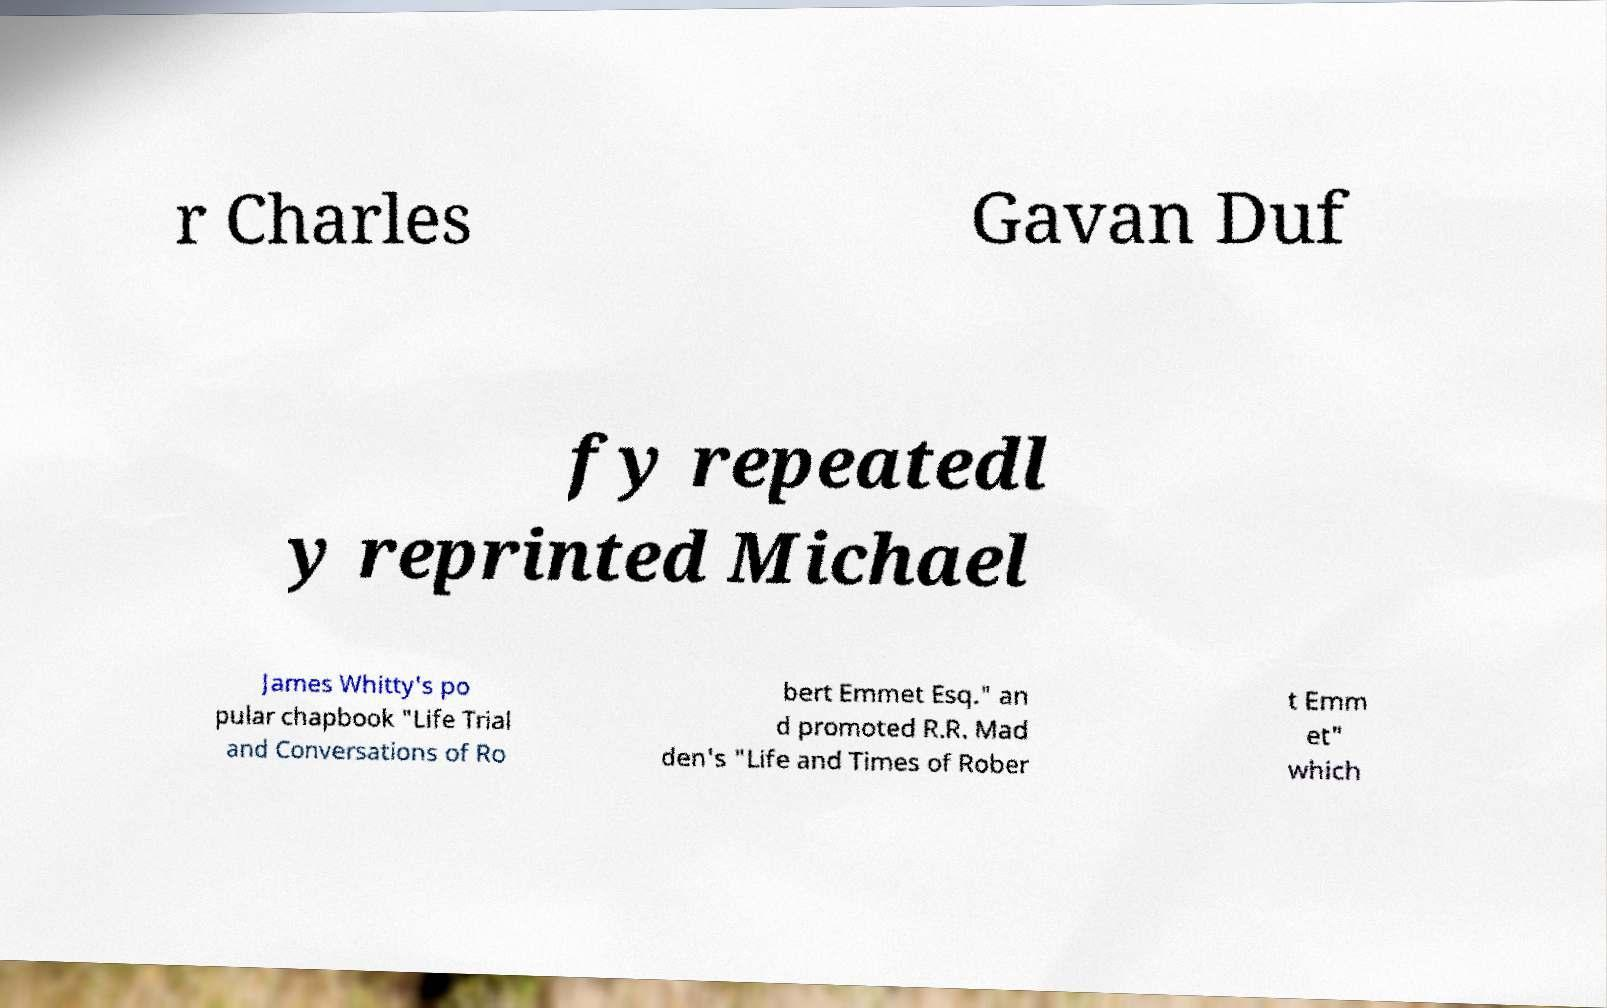There's text embedded in this image that I need extracted. Can you transcribe it verbatim? r Charles Gavan Duf fy repeatedl y reprinted Michael James Whitty's po pular chapbook "Life Trial and Conversations of Ro bert Emmet Esq." an d promoted R.R. Mad den's "Life and Times of Rober t Emm et" which 